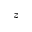<formula> <loc_0><loc_0><loc_500><loc_500>z</formula> 